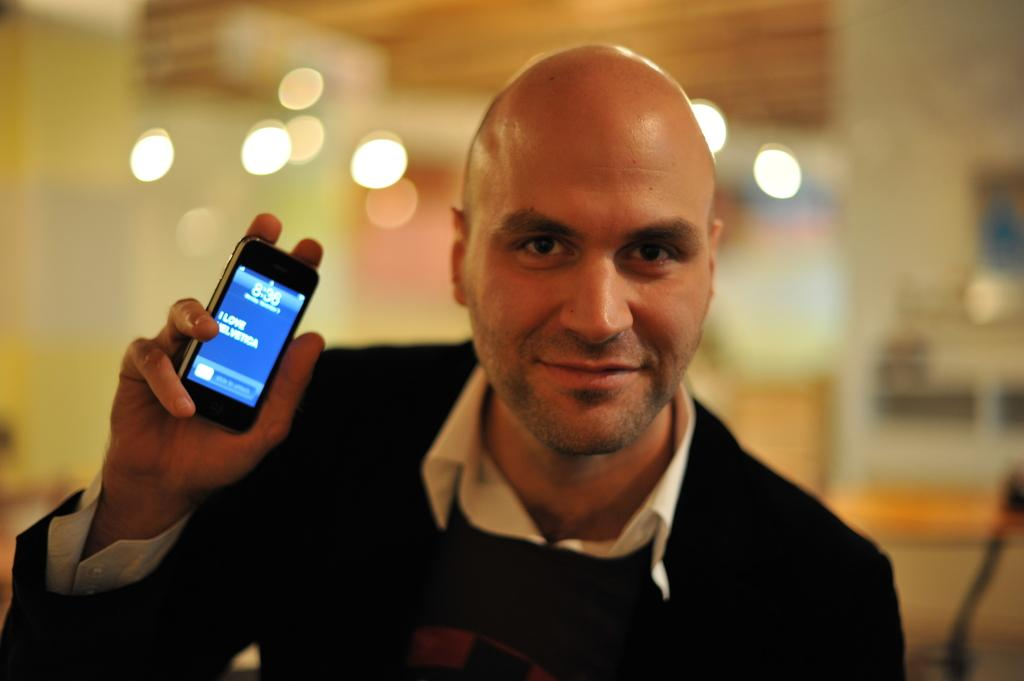What is the main subject of the image? The main subject of the image is a man. What is the man holding in his hand? The man is holding a mobile phone in his hand. What type of oil is the man using to run the mobile phone in the image? There is no oil present in the image, and the man is not running the mobile phone; he is simply holding it. 